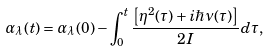Convert formula to latex. <formula><loc_0><loc_0><loc_500><loc_500>\alpha _ { \lambda } ( t ) = \alpha _ { \lambda } ( 0 ) - \int ^ { t } _ { 0 } \frac { \left [ \eta ^ { 2 } ( \tau ) + i \hbar { \nu } ( \tau ) \right ] } { 2 I } d \tau ,</formula> 